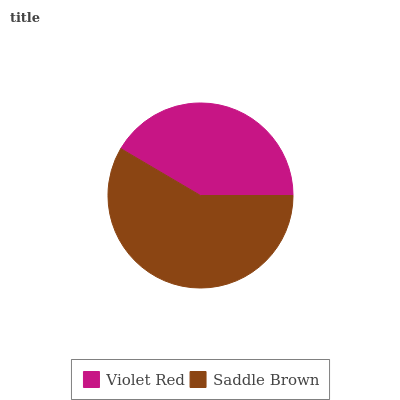Is Violet Red the minimum?
Answer yes or no. Yes. Is Saddle Brown the maximum?
Answer yes or no. Yes. Is Saddle Brown the minimum?
Answer yes or no. No. Is Saddle Brown greater than Violet Red?
Answer yes or no. Yes. Is Violet Red less than Saddle Brown?
Answer yes or no. Yes. Is Violet Red greater than Saddle Brown?
Answer yes or no. No. Is Saddle Brown less than Violet Red?
Answer yes or no. No. Is Saddle Brown the high median?
Answer yes or no. Yes. Is Violet Red the low median?
Answer yes or no. Yes. Is Violet Red the high median?
Answer yes or no. No. Is Saddle Brown the low median?
Answer yes or no. No. 